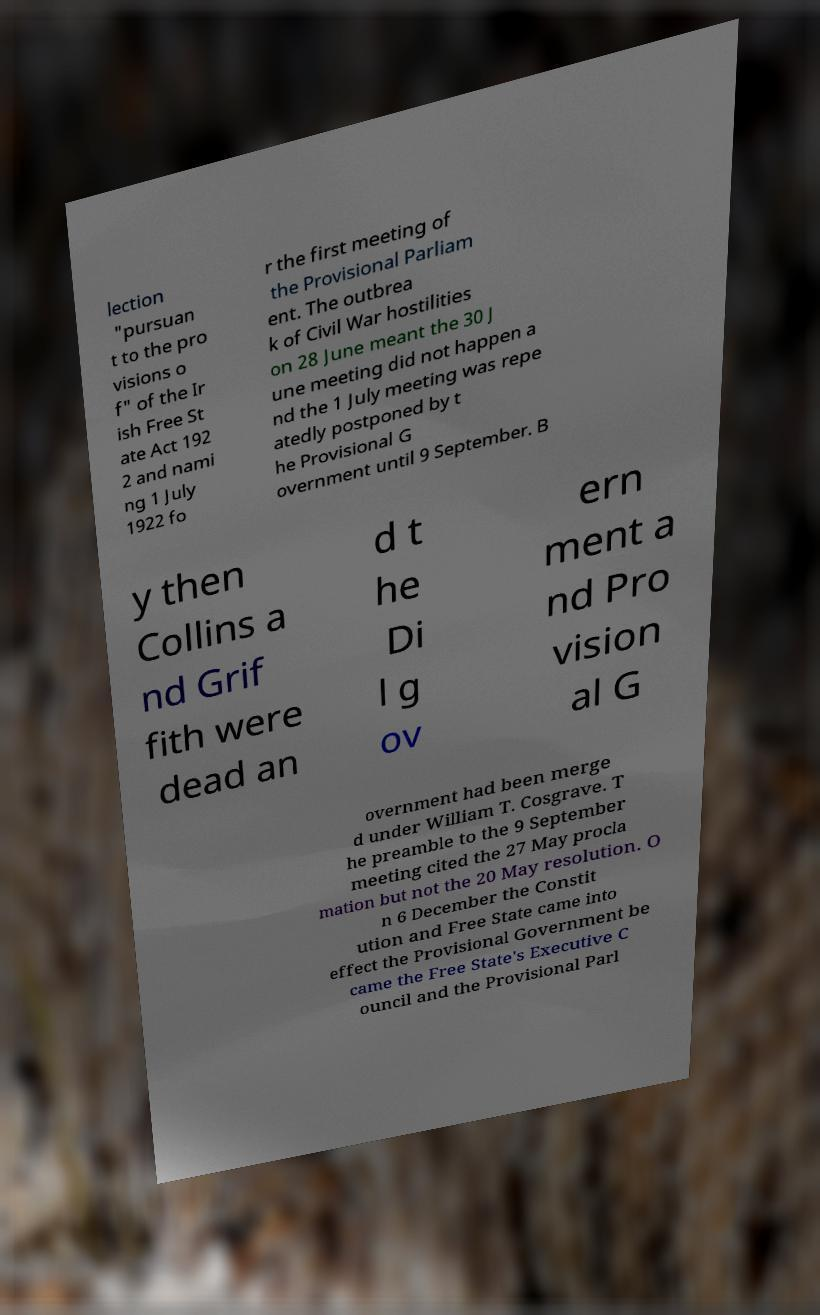Could you assist in decoding the text presented in this image and type it out clearly? lection "pursuan t to the pro visions o f" of the Ir ish Free St ate Act 192 2 and nami ng 1 July 1922 fo r the first meeting of the Provisional Parliam ent. The outbrea k of Civil War hostilities on 28 June meant the 30 J une meeting did not happen a nd the 1 July meeting was repe atedly postponed by t he Provisional G overnment until 9 September. B y then Collins a nd Grif fith were dead an d t he Di l g ov ern ment a nd Pro vision al G overnment had been merge d under William T. Cosgrave. T he preamble to the 9 September meeting cited the 27 May procla mation but not the 20 May resolution. O n 6 December the Constit ution and Free State came into effect the Provisional Government be came the Free State's Executive C ouncil and the Provisional Parl 